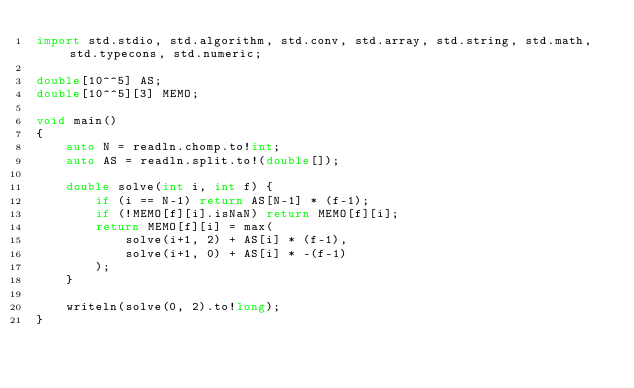Convert code to text. <code><loc_0><loc_0><loc_500><loc_500><_D_>import std.stdio, std.algorithm, std.conv, std.array, std.string, std.math, std.typecons, std.numeric;

double[10^^5] AS;
double[10^^5][3] MEMO;

void main()
{
    auto N = readln.chomp.to!int;
    auto AS = readln.split.to!(double[]);

    double solve(int i, int f) {
        if (i == N-1) return AS[N-1] * (f-1);
        if (!MEMO[f][i].isNaN) return MEMO[f][i];
        return MEMO[f][i] = max(
            solve(i+1, 2) + AS[i] * (f-1),
            solve(i+1, 0) + AS[i] * -(f-1)
        );
    }

    writeln(solve(0, 2).to!long);
}</code> 